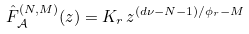<formula> <loc_0><loc_0><loc_500><loc_500>\hat { F } _ { \mathcal { A } } ^ { ( N , M ) } ( z ) = K _ { r } \, z ^ { ( d \nu - N - 1 ) / \phi _ { r } - M }</formula> 